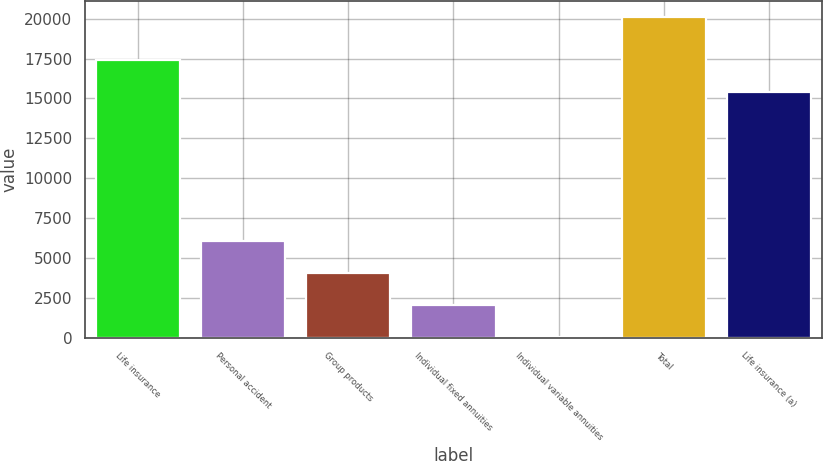Convert chart to OTSL. <chart><loc_0><loc_0><loc_500><loc_500><bar_chart><fcel>Life insurance<fcel>Personal accident<fcel>Group products<fcel>Individual fixed annuities<fcel>Individual variable annuities<fcel>Total<fcel>Life insurance (a)<nl><fcel>17403.1<fcel>6030.3<fcel>4022.2<fcel>2014.1<fcel>6<fcel>20087<fcel>15395<nl></chart> 